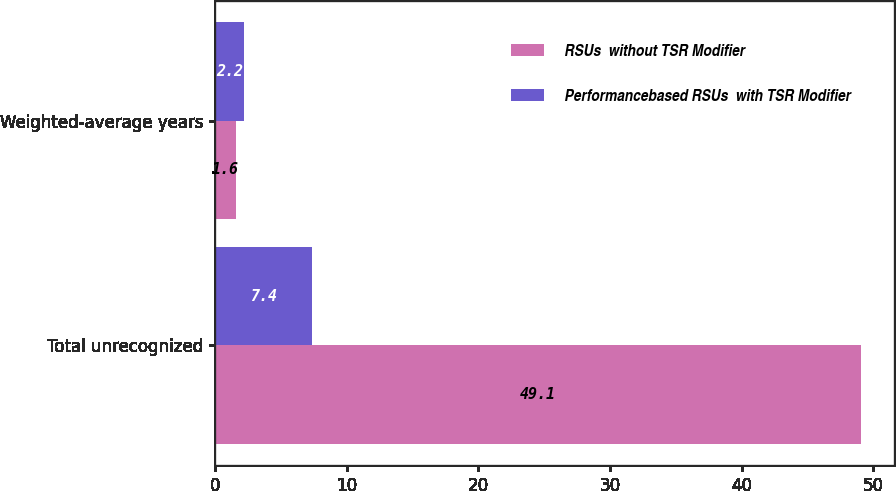Convert chart to OTSL. <chart><loc_0><loc_0><loc_500><loc_500><stacked_bar_chart><ecel><fcel>Total unrecognized<fcel>Weighted-average years<nl><fcel>RSUs  without TSR Modifier<fcel>49.1<fcel>1.6<nl><fcel>Performancebased RSUs  with TSR Modifier<fcel>7.4<fcel>2.2<nl></chart> 